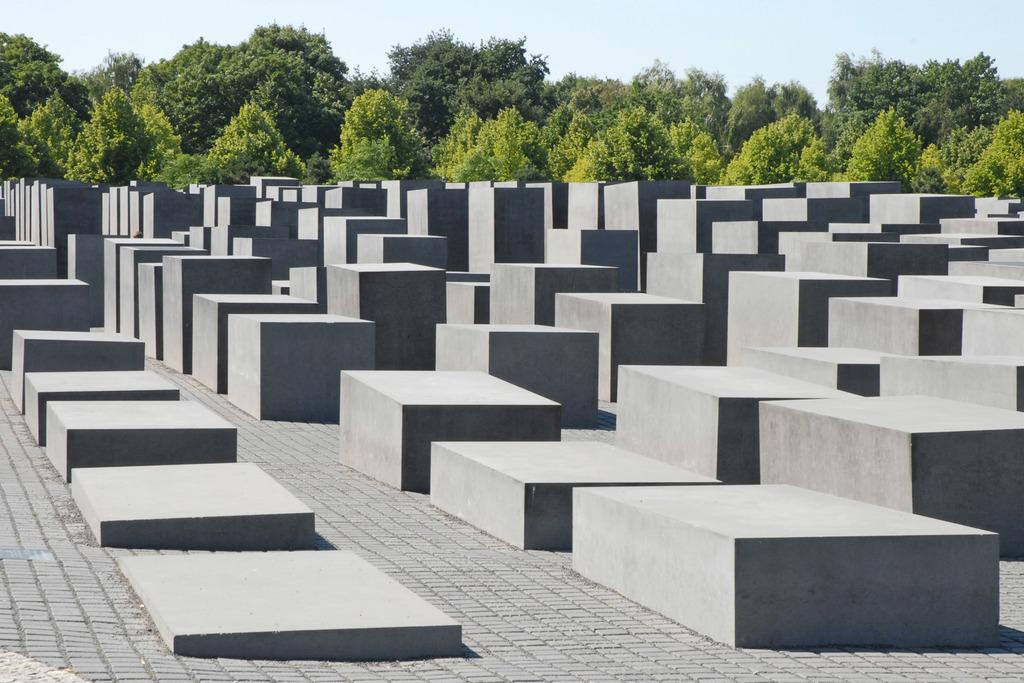What type of blocks can be seen in the image? There are blocks of cemetery in the image. How are the blocks arranged on the ground? The blocks are placed in an order on the ground. What can be seen in the background of the image? There is a group of trees and the sky visible in the background. What is the condition of the sky in the image? The sky appears to be cloudy in the image. What is the purpose of the fifth block in the image? There is no mention of a fifth block in the image, so we cannot determine its purpose. 